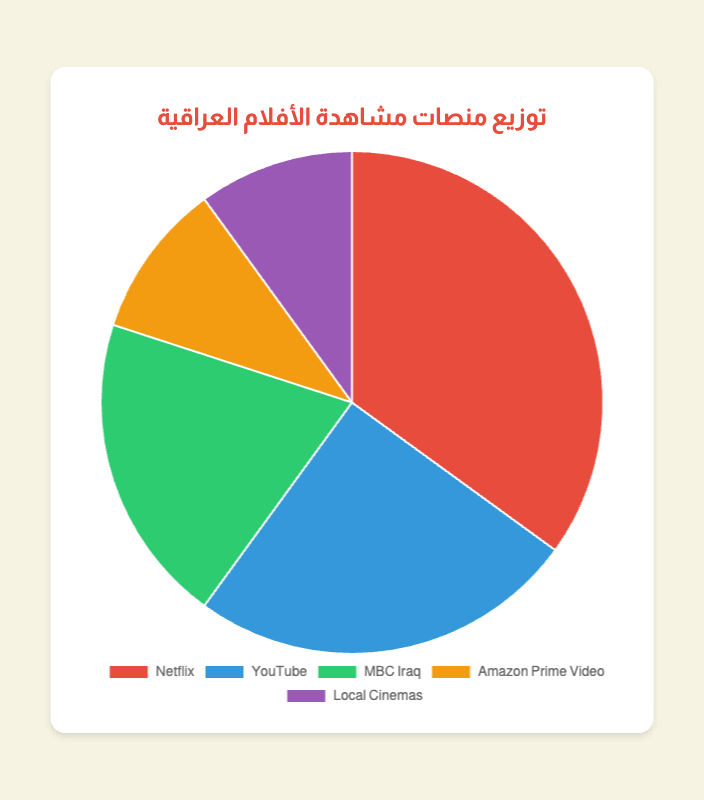What is the percentage of viewers watching Iraqi films on Netflix? You can directly see from the pie chart that the segment labeled "Netflix" covers 35% of the entire chart.
Answer: 35% Which platform has the least percentage of viewers? By comparing the sizes of the pie slices, you can see that "Amazon Prime Video" and "Local Cinemas" both have the smallest slices, each covering 10% of the chart.
Answer: Amazon Prime Video or Local Cinemas How much more popular is Netflix compared to Amazon Prime Video? The percentage for Netflix is 35% and for Amazon Prime Video it's 10%. Subtracting the smaller percentage from the larger one: 35% - 10% = 25%.
Answer: 25% What is the combined percentage of viewers for MBC Iraq and Local Cinemas? Adding the percentages for MBC Iraq (20%) and Local Cinemas (10%): 20% + 10% = 30%.
Answer: 30% If the total viewership is 100,000 people, how many watch on YouTube? Since 25% of the viewership is on YouTube, you calculate 25% of 100,000: 0.25 * 100,000 = 25,000.
Answer: 25,000 Between YouTube and MBC Iraq, which platform is more popular and by how much? The percentage for YouTube is 25%, and for MBC Iraq, it's 20%. Subtracting the smaller percentage from the larger one: 25% - 20% = 5%.
Answer: YouTube by 5% Which platform has the second largest percentage of viewers? From the pie chart, after Netflix (35%), the next largest slice is YouTube, which is 25%.
Answer: YouTube What is the percentage difference between the most and least popular platforms? The most popular is Netflix at 35%, and the least popular are Amazon Prime Video and Local Cinemas at 10%. Subtracting the smaller percentage from the larger one: 35% - 10% = 25%.
Answer: 25% How many platforms have a lower percentage than 20%? According to the chart, both Amazon Prime Video and Local Cinemas have 10%, which is less than 20%. Thus, there are 2 such platforms.
Answer: 2 